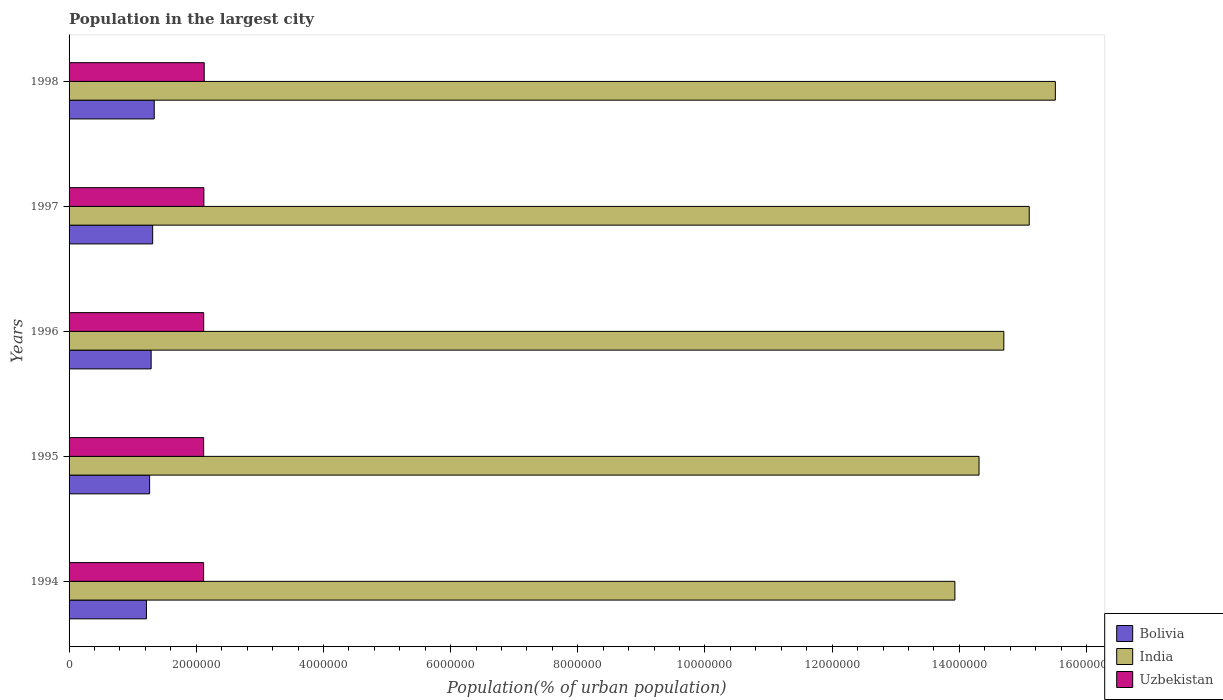How many different coloured bars are there?
Your answer should be very brief. 3. Are the number of bars per tick equal to the number of legend labels?
Provide a succinct answer. Yes. Are the number of bars on each tick of the Y-axis equal?
Provide a succinct answer. Yes. How many bars are there on the 1st tick from the top?
Make the answer very short. 3. How many bars are there on the 4th tick from the bottom?
Ensure brevity in your answer.  3. In how many cases, is the number of bars for a given year not equal to the number of legend labels?
Give a very brief answer. 0. What is the population in the largest city in Bolivia in 1994?
Offer a terse response. 1.22e+06. Across all years, what is the maximum population in the largest city in Bolivia?
Ensure brevity in your answer.  1.34e+06. Across all years, what is the minimum population in the largest city in Uzbekistan?
Your answer should be compact. 2.12e+06. In which year was the population in the largest city in India maximum?
Ensure brevity in your answer.  1998. In which year was the population in the largest city in Uzbekistan minimum?
Give a very brief answer. 1994. What is the total population in the largest city in Bolivia in the graph?
Your answer should be very brief. 6.43e+06. What is the difference between the population in the largest city in India in 1995 and that in 1998?
Give a very brief answer. -1.20e+06. What is the difference between the population in the largest city in India in 1994 and the population in the largest city in Bolivia in 1995?
Provide a succinct answer. 1.27e+07. What is the average population in the largest city in Bolivia per year?
Ensure brevity in your answer.  1.29e+06. In the year 1997, what is the difference between the population in the largest city in Uzbekistan and population in the largest city in Bolivia?
Offer a very short reply. 8.05e+05. What is the ratio of the population in the largest city in India in 1996 to that in 1998?
Provide a succinct answer. 0.95. Is the difference between the population in the largest city in Uzbekistan in 1995 and 1998 greater than the difference between the population in the largest city in Bolivia in 1995 and 1998?
Ensure brevity in your answer.  Yes. What is the difference between the highest and the second highest population in the largest city in Bolivia?
Provide a succinct answer. 2.45e+04. What is the difference between the highest and the lowest population in the largest city in Bolivia?
Offer a terse response. 1.22e+05. Is the sum of the population in the largest city in Uzbekistan in 1994 and 1997 greater than the maximum population in the largest city in India across all years?
Your answer should be compact. No. What does the 3rd bar from the top in 1998 represents?
Ensure brevity in your answer.  Bolivia. What does the 2nd bar from the bottom in 1998 represents?
Offer a very short reply. India. Is it the case that in every year, the sum of the population in the largest city in India and population in the largest city in Uzbekistan is greater than the population in the largest city in Bolivia?
Your answer should be very brief. Yes. How many years are there in the graph?
Your answer should be compact. 5. What is the difference between two consecutive major ticks on the X-axis?
Give a very brief answer. 2.00e+06. Does the graph contain any zero values?
Your answer should be very brief. No. Does the graph contain grids?
Ensure brevity in your answer.  No. How are the legend labels stacked?
Ensure brevity in your answer.  Vertical. What is the title of the graph?
Ensure brevity in your answer.  Population in the largest city. What is the label or title of the X-axis?
Your answer should be very brief. Population(% of urban population). What is the Population(% of urban population) of Bolivia in 1994?
Give a very brief answer. 1.22e+06. What is the Population(% of urban population) of India in 1994?
Keep it short and to the point. 1.39e+07. What is the Population(% of urban population) in Uzbekistan in 1994?
Provide a succinct answer. 2.12e+06. What is the Population(% of urban population) of Bolivia in 1995?
Your answer should be compact. 1.27e+06. What is the Population(% of urban population) in India in 1995?
Keep it short and to the point. 1.43e+07. What is the Population(% of urban population) in Uzbekistan in 1995?
Keep it short and to the point. 2.12e+06. What is the Population(% of urban population) of Bolivia in 1996?
Offer a very short reply. 1.29e+06. What is the Population(% of urban population) in India in 1996?
Keep it short and to the point. 1.47e+07. What is the Population(% of urban population) of Uzbekistan in 1996?
Offer a terse response. 2.12e+06. What is the Population(% of urban population) of Bolivia in 1997?
Make the answer very short. 1.31e+06. What is the Population(% of urban population) of India in 1997?
Offer a very short reply. 1.51e+07. What is the Population(% of urban population) of Uzbekistan in 1997?
Make the answer very short. 2.12e+06. What is the Population(% of urban population) of Bolivia in 1998?
Provide a short and direct response. 1.34e+06. What is the Population(% of urban population) in India in 1998?
Your answer should be very brief. 1.55e+07. What is the Population(% of urban population) in Uzbekistan in 1998?
Provide a short and direct response. 2.13e+06. Across all years, what is the maximum Population(% of urban population) of Bolivia?
Make the answer very short. 1.34e+06. Across all years, what is the maximum Population(% of urban population) of India?
Give a very brief answer. 1.55e+07. Across all years, what is the maximum Population(% of urban population) of Uzbekistan?
Make the answer very short. 2.13e+06. Across all years, what is the minimum Population(% of urban population) in Bolivia?
Make the answer very short. 1.22e+06. Across all years, what is the minimum Population(% of urban population) of India?
Offer a very short reply. 1.39e+07. Across all years, what is the minimum Population(% of urban population) in Uzbekistan?
Keep it short and to the point. 2.12e+06. What is the total Population(% of urban population) in Bolivia in the graph?
Your answer should be very brief. 6.43e+06. What is the total Population(% of urban population) of India in the graph?
Offer a terse response. 7.36e+07. What is the total Population(% of urban population) in Uzbekistan in the graph?
Offer a terse response. 1.06e+07. What is the difference between the Population(% of urban population) in Bolivia in 1994 and that in 1995?
Provide a short and direct response. -5.02e+04. What is the difference between the Population(% of urban population) of India in 1994 and that in 1995?
Your answer should be very brief. -3.79e+05. What is the difference between the Population(% of urban population) of Uzbekistan in 1994 and that in 1995?
Provide a short and direct response. -700. What is the difference between the Population(% of urban population) in Bolivia in 1994 and that in 1996?
Your answer should be compact. -7.38e+04. What is the difference between the Population(% of urban population) of India in 1994 and that in 1996?
Provide a short and direct response. -7.69e+05. What is the difference between the Population(% of urban population) of Uzbekistan in 1994 and that in 1996?
Your answer should be compact. -1402. What is the difference between the Population(% of urban population) of Bolivia in 1994 and that in 1997?
Your answer should be compact. -9.79e+04. What is the difference between the Population(% of urban population) of India in 1994 and that in 1997?
Keep it short and to the point. -1.17e+06. What is the difference between the Population(% of urban population) of Uzbekistan in 1994 and that in 1997?
Your response must be concise. -4358. What is the difference between the Population(% of urban population) in Bolivia in 1994 and that in 1998?
Offer a terse response. -1.22e+05. What is the difference between the Population(% of urban population) of India in 1994 and that in 1998?
Your answer should be compact. -1.58e+06. What is the difference between the Population(% of urban population) in Uzbekistan in 1994 and that in 1998?
Keep it short and to the point. -9618. What is the difference between the Population(% of urban population) in Bolivia in 1995 and that in 1996?
Ensure brevity in your answer.  -2.37e+04. What is the difference between the Population(% of urban population) in India in 1995 and that in 1996?
Provide a short and direct response. -3.90e+05. What is the difference between the Population(% of urban population) of Uzbekistan in 1995 and that in 1996?
Your answer should be very brief. -702. What is the difference between the Population(% of urban population) in Bolivia in 1995 and that in 1997?
Offer a terse response. -4.77e+04. What is the difference between the Population(% of urban population) in India in 1995 and that in 1997?
Keep it short and to the point. -7.90e+05. What is the difference between the Population(% of urban population) of Uzbekistan in 1995 and that in 1997?
Keep it short and to the point. -3658. What is the difference between the Population(% of urban population) of Bolivia in 1995 and that in 1998?
Offer a very short reply. -7.23e+04. What is the difference between the Population(% of urban population) of India in 1995 and that in 1998?
Your answer should be very brief. -1.20e+06. What is the difference between the Population(% of urban population) of Uzbekistan in 1995 and that in 1998?
Provide a succinct answer. -8918. What is the difference between the Population(% of urban population) in Bolivia in 1996 and that in 1997?
Your answer should be very brief. -2.41e+04. What is the difference between the Population(% of urban population) in India in 1996 and that in 1997?
Keep it short and to the point. -4.00e+05. What is the difference between the Population(% of urban population) of Uzbekistan in 1996 and that in 1997?
Provide a short and direct response. -2956. What is the difference between the Population(% of urban population) of Bolivia in 1996 and that in 1998?
Keep it short and to the point. -4.86e+04. What is the difference between the Population(% of urban population) in India in 1996 and that in 1998?
Give a very brief answer. -8.11e+05. What is the difference between the Population(% of urban population) in Uzbekistan in 1996 and that in 1998?
Make the answer very short. -8216. What is the difference between the Population(% of urban population) in Bolivia in 1997 and that in 1998?
Make the answer very short. -2.45e+04. What is the difference between the Population(% of urban population) of India in 1997 and that in 1998?
Make the answer very short. -4.11e+05. What is the difference between the Population(% of urban population) in Uzbekistan in 1997 and that in 1998?
Give a very brief answer. -5260. What is the difference between the Population(% of urban population) in Bolivia in 1994 and the Population(% of urban population) in India in 1995?
Your answer should be very brief. -1.31e+07. What is the difference between the Population(% of urban population) in Bolivia in 1994 and the Population(% of urban population) in Uzbekistan in 1995?
Provide a succinct answer. -9.00e+05. What is the difference between the Population(% of urban population) of India in 1994 and the Population(% of urban population) of Uzbekistan in 1995?
Provide a succinct answer. 1.18e+07. What is the difference between the Population(% of urban population) of Bolivia in 1994 and the Population(% of urban population) of India in 1996?
Make the answer very short. -1.35e+07. What is the difference between the Population(% of urban population) of Bolivia in 1994 and the Population(% of urban population) of Uzbekistan in 1996?
Give a very brief answer. -9.00e+05. What is the difference between the Population(% of urban population) of India in 1994 and the Population(% of urban population) of Uzbekistan in 1996?
Your response must be concise. 1.18e+07. What is the difference between the Population(% of urban population) of Bolivia in 1994 and the Population(% of urban population) of India in 1997?
Your answer should be very brief. -1.39e+07. What is the difference between the Population(% of urban population) in Bolivia in 1994 and the Population(% of urban population) in Uzbekistan in 1997?
Your response must be concise. -9.03e+05. What is the difference between the Population(% of urban population) in India in 1994 and the Population(% of urban population) in Uzbekistan in 1997?
Offer a very short reply. 1.18e+07. What is the difference between the Population(% of urban population) in Bolivia in 1994 and the Population(% of urban population) in India in 1998?
Ensure brevity in your answer.  -1.43e+07. What is the difference between the Population(% of urban population) in Bolivia in 1994 and the Population(% of urban population) in Uzbekistan in 1998?
Offer a very short reply. -9.09e+05. What is the difference between the Population(% of urban population) of India in 1994 and the Population(% of urban population) of Uzbekistan in 1998?
Give a very brief answer. 1.18e+07. What is the difference between the Population(% of urban population) in Bolivia in 1995 and the Population(% of urban population) in India in 1996?
Your answer should be very brief. -1.34e+07. What is the difference between the Population(% of urban population) in Bolivia in 1995 and the Population(% of urban population) in Uzbekistan in 1996?
Make the answer very short. -8.50e+05. What is the difference between the Population(% of urban population) in India in 1995 and the Population(% of urban population) in Uzbekistan in 1996?
Offer a very short reply. 1.22e+07. What is the difference between the Population(% of urban population) of Bolivia in 1995 and the Population(% of urban population) of India in 1997?
Provide a short and direct response. -1.38e+07. What is the difference between the Population(% of urban population) of Bolivia in 1995 and the Population(% of urban population) of Uzbekistan in 1997?
Ensure brevity in your answer.  -8.53e+05. What is the difference between the Population(% of urban population) of India in 1995 and the Population(% of urban population) of Uzbekistan in 1997?
Provide a short and direct response. 1.22e+07. What is the difference between the Population(% of urban population) in Bolivia in 1995 and the Population(% of urban population) in India in 1998?
Provide a succinct answer. -1.42e+07. What is the difference between the Population(% of urban population) of Bolivia in 1995 and the Population(% of urban population) of Uzbekistan in 1998?
Your answer should be very brief. -8.58e+05. What is the difference between the Population(% of urban population) of India in 1995 and the Population(% of urban population) of Uzbekistan in 1998?
Offer a terse response. 1.22e+07. What is the difference between the Population(% of urban population) in Bolivia in 1996 and the Population(% of urban population) in India in 1997?
Offer a very short reply. -1.38e+07. What is the difference between the Population(% of urban population) in Bolivia in 1996 and the Population(% of urban population) in Uzbekistan in 1997?
Keep it short and to the point. -8.30e+05. What is the difference between the Population(% of urban population) of India in 1996 and the Population(% of urban population) of Uzbekistan in 1997?
Provide a short and direct response. 1.26e+07. What is the difference between the Population(% of urban population) in Bolivia in 1996 and the Population(% of urban population) in India in 1998?
Ensure brevity in your answer.  -1.42e+07. What is the difference between the Population(% of urban population) in Bolivia in 1996 and the Population(% of urban population) in Uzbekistan in 1998?
Provide a short and direct response. -8.35e+05. What is the difference between the Population(% of urban population) in India in 1996 and the Population(% of urban population) in Uzbekistan in 1998?
Your answer should be compact. 1.26e+07. What is the difference between the Population(% of urban population) of Bolivia in 1997 and the Population(% of urban population) of India in 1998?
Your answer should be compact. -1.42e+07. What is the difference between the Population(% of urban population) in Bolivia in 1997 and the Population(% of urban population) in Uzbekistan in 1998?
Provide a short and direct response. -8.11e+05. What is the difference between the Population(% of urban population) in India in 1997 and the Population(% of urban population) in Uzbekistan in 1998?
Your response must be concise. 1.30e+07. What is the average Population(% of urban population) in Bolivia per year?
Offer a terse response. 1.29e+06. What is the average Population(% of urban population) in India per year?
Offer a very short reply. 1.47e+07. What is the average Population(% of urban population) of Uzbekistan per year?
Keep it short and to the point. 2.12e+06. In the year 1994, what is the difference between the Population(% of urban population) of Bolivia and Population(% of urban population) of India?
Your answer should be compact. -1.27e+07. In the year 1994, what is the difference between the Population(% of urban population) of Bolivia and Population(% of urban population) of Uzbekistan?
Your response must be concise. -8.99e+05. In the year 1994, what is the difference between the Population(% of urban population) of India and Population(% of urban population) of Uzbekistan?
Your answer should be very brief. 1.18e+07. In the year 1995, what is the difference between the Population(% of urban population) in Bolivia and Population(% of urban population) in India?
Provide a succinct answer. -1.30e+07. In the year 1995, what is the difference between the Population(% of urban population) in Bolivia and Population(% of urban population) in Uzbekistan?
Keep it short and to the point. -8.50e+05. In the year 1995, what is the difference between the Population(% of urban population) of India and Population(% of urban population) of Uzbekistan?
Your answer should be very brief. 1.22e+07. In the year 1996, what is the difference between the Population(% of urban population) of Bolivia and Population(% of urban population) of India?
Your response must be concise. -1.34e+07. In the year 1996, what is the difference between the Population(% of urban population) in Bolivia and Population(% of urban population) in Uzbekistan?
Offer a terse response. -8.27e+05. In the year 1996, what is the difference between the Population(% of urban population) of India and Population(% of urban population) of Uzbekistan?
Provide a short and direct response. 1.26e+07. In the year 1997, what is the difference between the Population(% of urban population) in Bolivia and Population(% of urban population) in India?
Your answer should be very brief. -1.38e+07. In the year 1997, what is the difference between the Population(% of urban population) in Bolivia and Population(% of urban population) in Uzbekistan?
Your response must be concise. -8.05e+05. In the year 1997, what is the difference between the Population(% of urban population) of India and Population(% of urban population) of Uzbekistan?
Make the answer very short. 1.30e+07. In the year 1998, what is the difference between the Population(% of urban population) of Bolivia and Population(% of urban population) of India?
Your answer should be very brief. -1.42e+07. In the year 1998, what is the difference between the Population(% of urban population) in Bolivia and Population(% of urban population) in Uzbekistan?
Your answer should be compact. -7.86e+05. In the year 1998, what is the difference between the Population(% of urban population) of India and Population(% of urban population) of Uzbekistan?
Offer a terse response. 1.34e+07. What is the ratio of the Population(% of urban population) in Bolivia in 1994 to that in 1995?
Offer a very short reply. 0.96. What is the ratio of the Population(% of urban population) of India in 1994 to that in 1995?
Offer a terse response. 0.97. What is the ratio of the Population(% of urban population) of Uzbekistan in 1994 to that in 1995?
Your answer should be very brief. 1. What is the ratio of the Population(% of urban population) of Bolivia in 1994 to that in 1996?
Your answer should be compact. 0.94. What is the ratio of the Population(% of urban population) in India in 1994 to that in 1996?
Offer a terse response. 0.95. What is the ratio of the Population(% of urban population) of Uzbekistan in 1994 to that in 1996?
Provide a short and direct response. 1. What is the ratio of the Population(% of urban population) in Bolivia in 1994 to that in 1997?
Make the answer very short. 0.93. What is the ratio of the Population(% of urban population) in India in 1994 to that in 1997?
Your answer should be very brief. 0.92. What is the ratio of the Population(% of urban population) of Bolivia in 1994 to that in 1998?
Give a very brief answer. 0.91. What is the ratio of the Population(% of urban population) in India in 1994 to that in 1998?
Keep it short and to the point. 0.9. What is the ratio of the Population(% of urban population) in Bolivia in 1995 to that in 1996?
Keep it short and to the point. 0.98. What is the ratio of the Population(% of urban population) in India in 1995 to that in 1996?
Offer a terse response. 0.97. What is the ratio of the Population(% of urban population) in Uzbekistan in 1995 to that in 1996?
Give a very brief answer. 1. What is the ratio of the Population(% of urban population) of Bolivia in 1995 to that in 1997?
Provide a short and direct response. 0.96. What is the ratio of the Population(% of urban population) of India in 1995 to that in 1997?
Your answer should be compact. 0.95. What is the ratio of the Population(% of urban population) of Uzbekistan in 1995 to that in 1997?
Ensure brevity in your answer.  1. What is the ratio of the Population(% of urban population) of Bolivia in 1995 to that in 1998?
Your response must be concise. 0.95. What is the ratio of the Population(% of urban population) in India in 1995 to that in 1998?
Provide a succinct answer. 0.92. What is the ratio of the Population(% of urban population) of Bolivia in 1996 to that in 1997?
Offer a terse response. 0.98. What is the ratio of the Population(% of urban population) of India in 1996 to that in 1997?
Provide a succinct answer. 0.97. What is the ratio of the Population(% of urban population) of Bolivia in 1996 to that in 1998?
Make the answer very short. 0.96. What is the ratio of the Population(% of urban population) in India in 1996 to that in 1998?
Keep it short and to the point. 0.95. What is the ratio of the Population(% of urban population) of Bolivia in 1997 to that in 1998?
Offer a terse response. 0.98. What is the ratio of the Population(% of urban population) of India in 1997 to that in 1998?
Provide a short and direct response. 0.97. What is the difference between the highest and the second highest Population(% of urban population) in Bolivia?
Ensure brevity in your answer.  2.45e+04. What is the difference between the highest and the second highest Population(% of urban population) of India?
Make the answer very short. 4.11e+05. What is the difference between the highest and the second highest Population(% of urban population) in Uzbekistan?
Offer a terse response. 5260. What is the difference between the highest and the lowest Population(% of urban population) in Bolivia?
Provide a short and direct response. 1.22e+05. What is the difference between the highest and the lowest Population(% of urban population) of India?
Offer a very short reply. 1.58e+06. What is the difference between the highest and the lowest Population(% of urban population) of Uzbekistan?
Provide a short and direct response. 9618. 